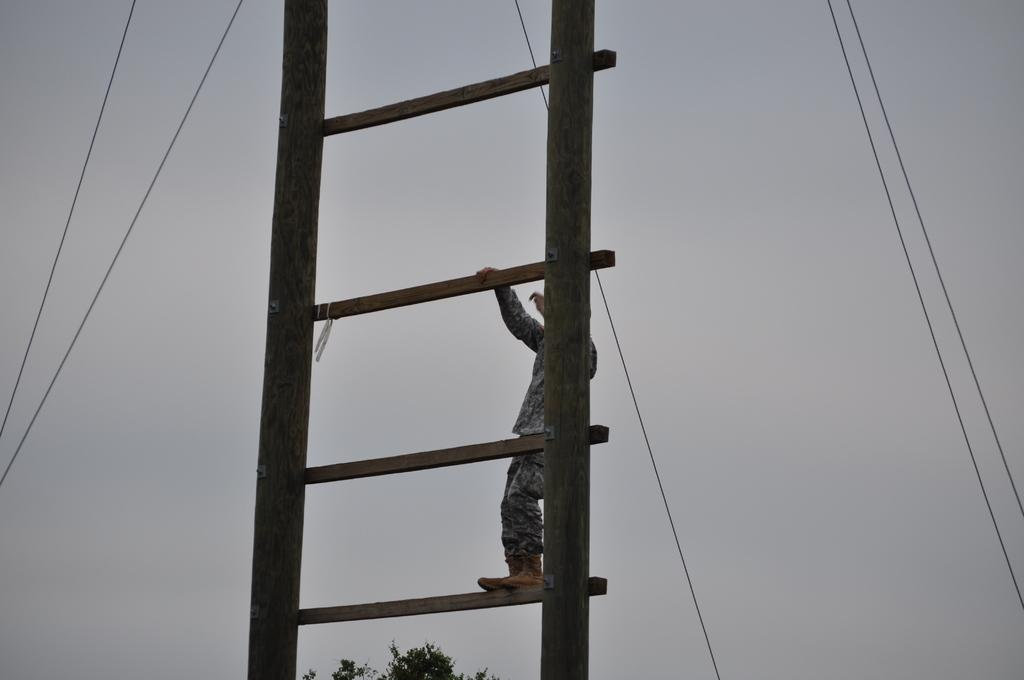What is the man in the image doing? The man is standing on an object in the image. What can be seen in the background of the image? There is a tree and wires in the background of the image. What is visible in the sky in the image? The sky is visible in the background of the image. What type of scarecrow is flying in the image? There is no scarecrow present in the image, and no objects are shown flying. 